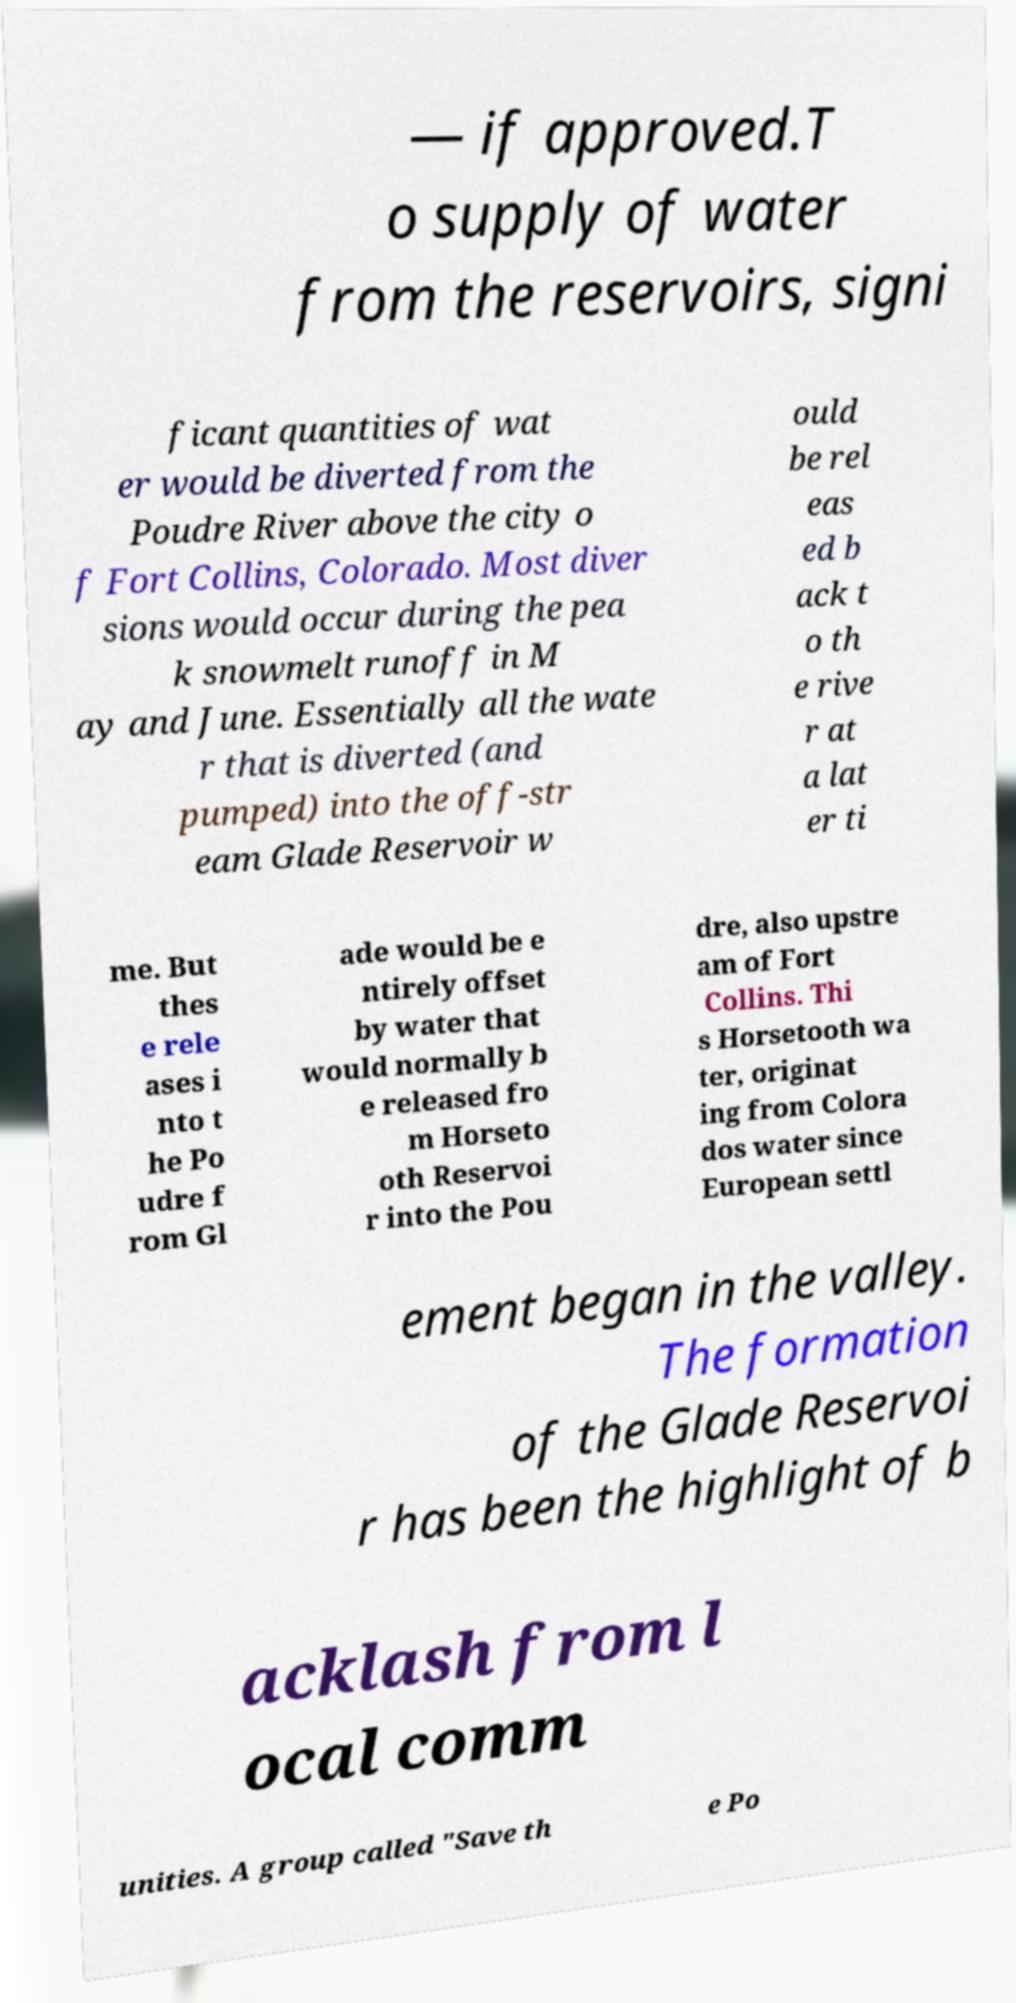Could you extract and type out the text from this image? — if approved.T o supply of water from the reservoirs, signi ficant quantities of wat er would be diverted from the Poudre River above the city o f Fort Collins, Colorado. Most diver sions would occur during the pea k snowmelt runoff in M ay and June. Essentially all the wate r that is diverted (and pumped) into the off-str eam Glade Reservoir w ould be rel eas ed b ack t o th e rive r at a lat er ti me. But thes e rele ases i nto t he Po udre f rom Gl ade would be e ntirely offset by water that would normally b e released fro m Horseto oth Reservoi r into the Pou dre, also upstre am of Fort Collins. Thi s Horsetooth wa ter, originat ing from Colora dos water since European settl ement began in the valley. The formation of the Glade Reservoi r has been the highlight of b acklash from l ocal comm unities. A group called "Save th e Po 